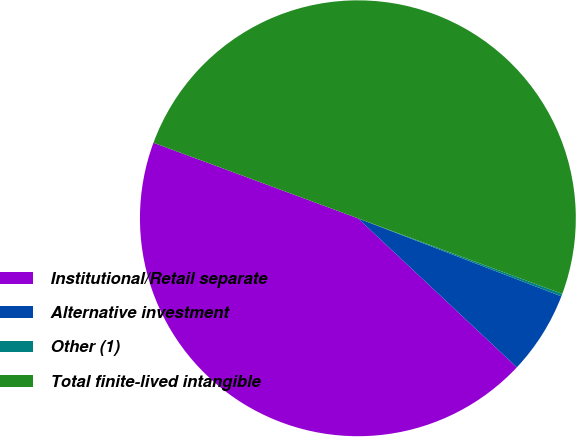Convert chart to OTSL. <chart><loc_0><loc_0><loc_500><loc_500><pie_chart><fcel>Institutional/Retail separate<fcel>Alternative investment<fcel>Other (1)<fcel>Total finite-lived intangible<nl><fcel>43.64%<fcel>6.16%<fcel>0.19%<fcel>50.0%<nl></chart> 